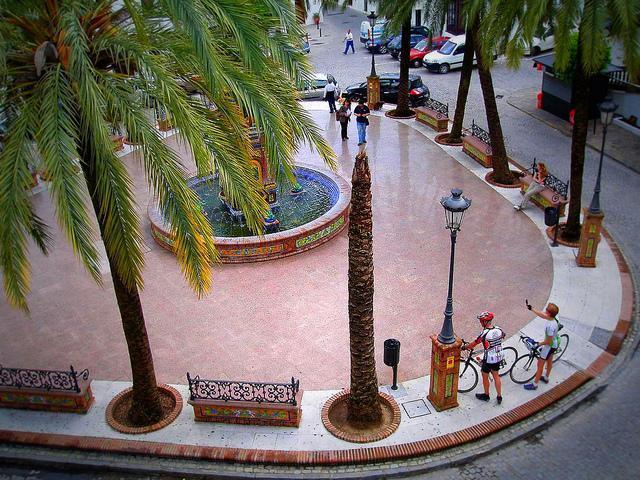How many benches are there?
Give a very brief answer. 2. How many elephants are in the image?
Give a very brief answer. 0. 